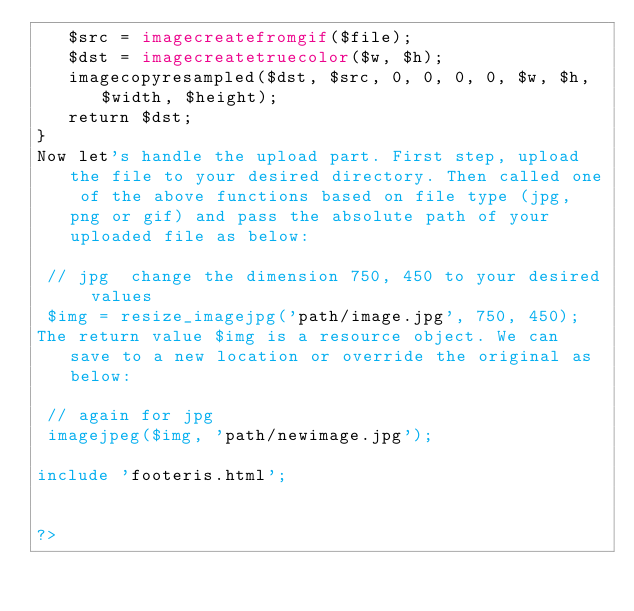Convert code to text. <code><loc_0><loc_0><loc_500><loc_500><_PHP_>   $src = imagecreatefromgif($file);
   $dst = imagecreatetruecolor($w, $h);
   imagecopyresampled($dst, $src, 0, 0, 0, 0, $w, $h, $width, $height);
   return $dst;
}
Now let's handle the upload part. First step, upload the file to your desired directory. Then called one of the above functions based on file type (jpg, png or gif) and pass the absolute path of your uploaded file as below:

 // jpg  change the dimension 750, 450 to your desired values
 $img = resize_imagejpg('path/image.jpg', 750, 450);
The return value $img is a resource object. We can save to a new location or override the original as below:

 // again for jpg
 imagejpeg($img, 'path/newimage.jpg');

include 'footeris.html';


?>
</code> 